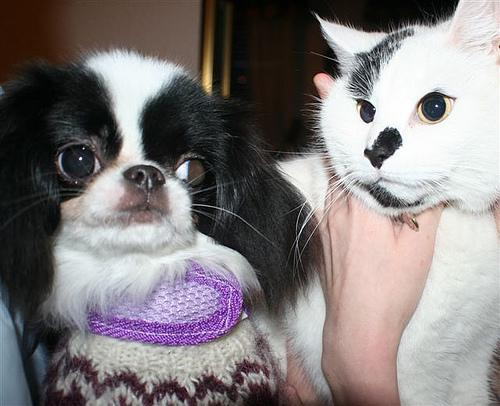How many cats are shown here? one 